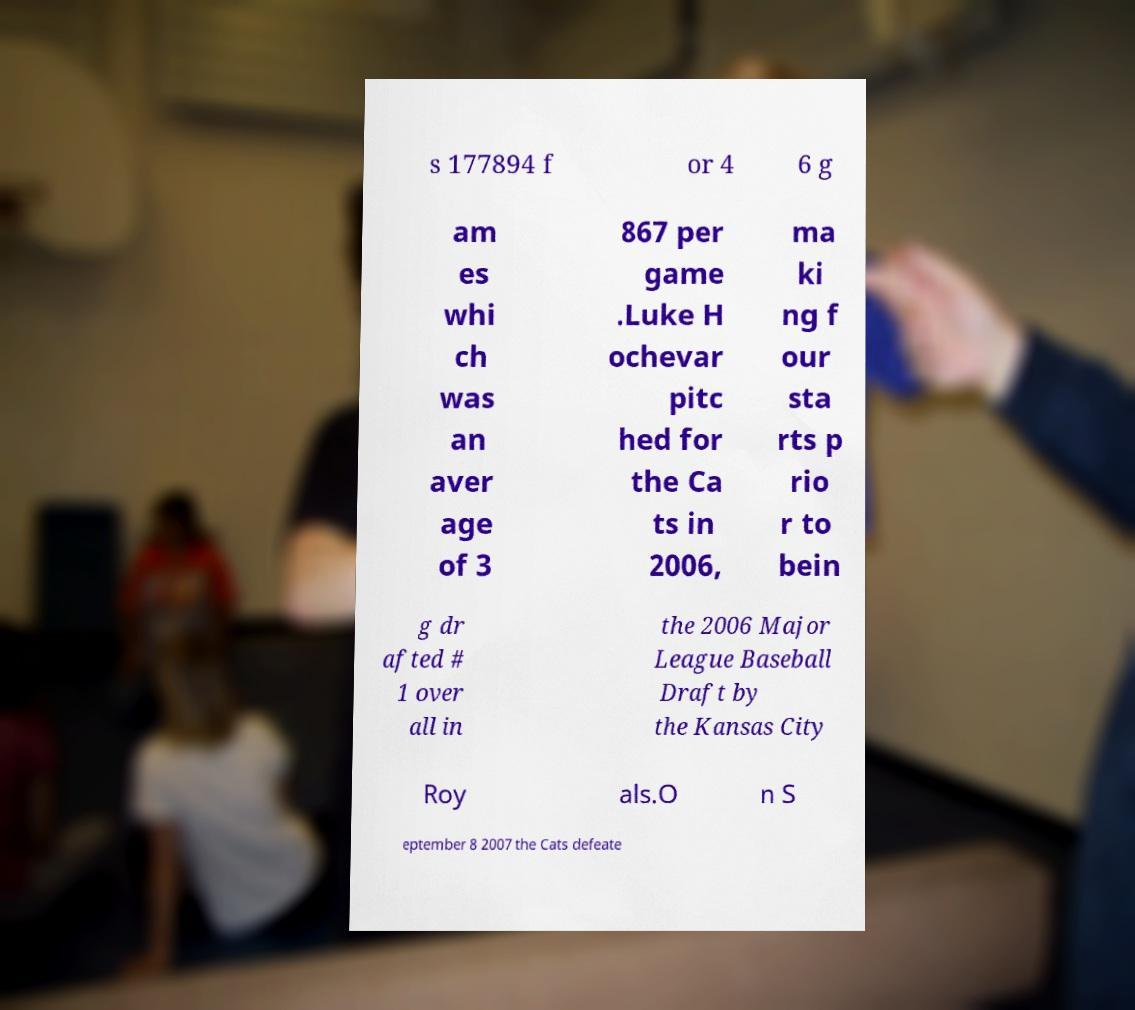There's text embedded in this image that I need extracted. Can you transcribe it verbatim? s 177894 f or 4 6 g am es whi ch was an aver age of 3 867 per game .Luke H ochevar pitc hed for the Ca ts in 2006, ma ki ng f our sta rts p rio r to bein g dr afted # 1 over all in the 2006 Major League Baseball Draft by the Kansas City Roy als.O n S eptember 8 2007 the Cats defeate 